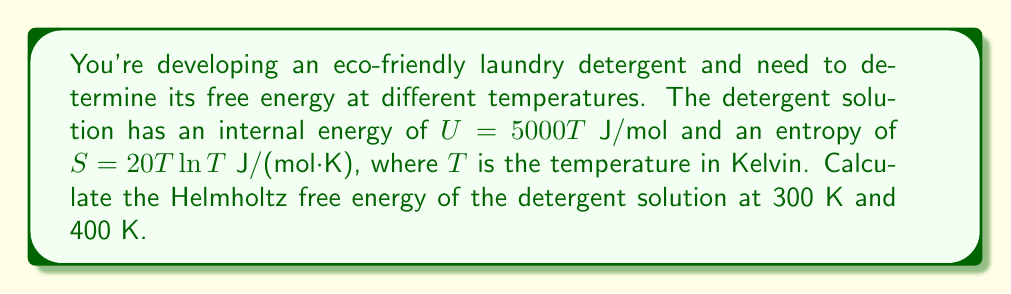Show me your answer to this math problem. To solve this problem, we'll follow these steps:

1) Recall the formula for Helmholtz free energy:
   $$ F = U - TS $$
   where $F$ is the Helmholtz free energy, $U$ is the internal energy, $T$ is the temperature, and $S$ is the entropy.

2) We're given:
   $$ U = 5000T \text{ J/mol} $$
   $$ S = 20T \ln T \text{ J/(mol·K)} $$

3) Let's calculate the free energy at 300 K:
   $$ F_{300} = U - TS $$
   $$ F_{300} = (5000 \cdot 300) - 300(20 \cdot 300 \ln 300) $$
   $$ F_{300} = 1,500,000 - 300(20 \cdot 300 \cdot 5.7038) $$
   $$ F_{300} = 1,500,000 - 1,026,684 $$
   $$ F_{300} = 473,316 \text{ J/mol} $$

4) Now, let's calculate the free energy at 400 K:
   $$ F_{400} = U - TS $$
   $$ F_{400} = (5000 \cdot 400) - 400(20 \cdot 400 \ln 400) $$
   $$ F_{400} = 2,000,000 - 400(20 \cdot 400 \cdot 5.9915) $$
   $$ F_{400} = 2,000,000 - 1,917,280 $$
   $$ F_{400} = 82,720 \text{ J/mol} $$

5) We can see that as the temperature increases, the Helmholtz free energy decreases.
Answer: $F_{300} = 473,316 \text{ J/mol}$, $F_{400} = 82,720 \text{ J/mol}$ 